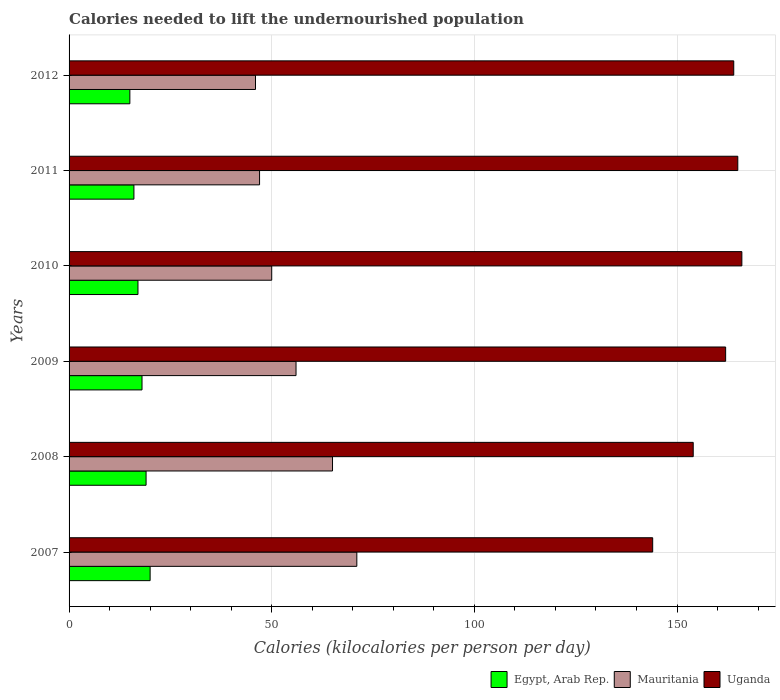How many different coloured bars are there?
Offer a very short reply. 3. Are the number of bars on each tick of the Y-axis equal?
Provide a short and direct response. Yes. How many bars are there on the 3rd tick from the bottom?
Provide a short and direct response. 3. What is the total calories needed to lift the undernourished population in Mauritania in 2010?
Your response must be concise. 50. Across all years, what is the maximum total calories needed to lift the undernourished population in Egypt, Arab Rep.?
Give a very brief answer. 20. Across all years, what is the minimum total calories needed to lift the undernourished population in Mauritania?
Your response must be concise. 46. In which year was the total calories needed to lift the undernourished population in Uganda maximum?
Give a very brief answer. 2010. In which year was the total calories needed to lift the undernourished population in Egypt, Arab Rep. minimum?
Provide a succinct answer. 2012. What is the total total calories needed to lift the undernourished population in Mauritania in the graph?
Give a very brief answer. 335. What is the difference between the total calories needed to lift the undernourished population in Egypt, Arab Rep. in 2007 and that in 2008?
Your answer should be compact. 1. What is the difference between the total calories needed to lift the undernourished population in Mauritania in 2009 and the total calories needed to lift the undernourished population in Egypt, Arab Rep. in 2007?
Provide a succinct answer. 36. What is the average total calories needed to lift the undernourished population in Mauritania per year?
Your response must be concise. 55.83. In the year 2008, what is the difference between the total calories needed to lift the undernourished population in Mauritania and total calories needed to lift the undernourished population in Egypt, Arab Rep.?
Your answer should be compact. 46. What is the ratio of the total calories needed to lift the undernourished population in Uganda in 2009 to that in 2011?
Offer a very short reply. 0.98. What is the difference between the highest and the lowest total calories needed to lift the undernourished population in Uganda?
Give a very brief answer. 22. In how many years, is the total calories needed to lift the undernourished population in Egypt, Arab Rep. greater than the average total calories needed to lift the undernourished population in Egypt, Arab Rep. taken over all years?
Offer a very short reply. 3. What does the 1st bar from the top in 2007 represents?
Offer a very short reply. Uganda. What does the 3rd bar from the bottom in 2009 represents?
Make the answer very short. Uganda. Is it the case that in every year, the sum of the total calories needed to lift the undernourished population in Egypt, Arab Rep. and total calories needed to lift the undernourished population in Uganda is greater than the total calories needed to lift the undernourished population in Mauritania?
Keep it short and to the point. Yes. How many bars are there?
Give a very brief answer. 18. Are all the bars in the graph horizontal?
Offer a terse response. Yes. Does the graph contain any zero values?
Your answer should be very brief. No. How are the legend labels stacked?
Provide a short and direct response. Horizontal. What is the title of the graph?
Give a very brief answer. Calories needed to lift the undernourished population. What is the label or title of the X-axis?
Offer a terse response. Calories (kilocalories per person per day). What is the label or title of the Y-axis?
Offer a terse response. Years. What is the Calories (kilocalories per person per day) in Mauritania in 2007?
Keep it short and to the point. 71. What is the Calories (kilocalories per person per day) in Uganda in 2007?
Offer a terse response. 144. What is the Calories (kilocalories per person per day) of Egypt, Arab Rep. in 2008?
Your answer should be compact. 19. What is the Calories (kilocalories per person per day) of Uganda in 2008?
Your response must be concise. 154. What is the Calories (kilocalories per person per day) of Uganda in 2009?
Provide a succinct answer. 162. What is the Calories (kilocalories per person per day) of Mauritania in 2010?
Ensure brevity in your answer.  50. What is the Calories (kilocalories per person per day) in Uganda in 2010?
Your response must be concise. 166. What is the Calories (kilocalories per person per day) in Egypt, Arab Rep. in 2011?
Provide a short and direct response. 16. What is the Calories (kilocalories per person per day) in Mauritania in 2011?
Offer a very short reply. 47. What is the Calories (kilocalories per person per day) in Uganda in 2011?
Your answer should be compact. 165. What is the Calories (kilocalories per person per day) in Egypt, Arab Rep. in 2012?
Keep it short and to the point. 15. What is the Calories (kilocalories per person per day) in Uganda in 2012?
Offer a terse response. 164. Across all years, what is the maximum Calories (kilocalories per person per day) in Egypt, Arab Rep.?
Provide a succinct answer. 20. Across all years, what is the maximum Calories (kilocalories per person per day) of Uganda?
Your answer should be compact. 166. Across all years, what is the minimum Calories (kilocalories per person per day) of Egypt, Arab Rep.?
Make the answer very short. 15. Across all years, what is the minimum Calories (kilocalories per person per day) of Uganda?
Provide a short and direct response. 144. What is the total Calories (kilocalories per person per day) of Egypt, Arab Rep. in the graph?
Your answer should be compact. 105. What is the total Calories (kilocalories per person per day) in Mauritania in the graph?
Make the answer very short. 335. What is the total Calories (kilocalories per person per day) in Uganda in the graph?
Give a very brief answer. 955. What is the difference between the Calories (kilocalories per person per day) of Mauritania in 2007 and that in 2008?
Provide a short and direct response. 6. What is the difference between the Calories (kilocalories per person per day) of Uganda in 2007 and that in 2008?
Your answer should be very brief. -10. What is the difference between the Calories (kilocalories per person per day) of Egypt, Arab Rep. in 2007 and that in 2009?
Your response must be concise. 2. What is the difference between the Calories (kilocalories per person per day) of Uganda in 2007 and that in 2009?
Give a very brief answer. -18. What is the difference between the Calories (kilocalories per person per day) in Egypt, Arab Rep. in 2007 and that in 2010?
Give a very brief answer. 3. What is the difference between the Calories (kilocalories per person per day) in Uganda in 2007 and that in 2010?
Your answer should be very brief. -22. What is the difference between the Calories (kilocalories per person per day) of Mauritania in 2007 and that in 2011?
Offer a very short reply. 24. What is the difference between the Calories (kilocalories per person per day) in Egypt, Arab Rep. in 2007 and that in 2012?
Offer a very short reply. 5. What is the difference between the Calories (kilocalories per person per day) in Uganda in 2007 and that in 2012?
Ensure brevity in your answer.  -20. What is the difference between the Calories (kilocalories per person per day) of Egypt, Arab Rep. in 2008 and that in 2009?
Make the answer very short. 1. What is the difference between the Calories (kilocalories per person per day) in Mauritania in 2008 and that in 2009?
Your answer should be very brief. 9. What is the difference between the Calories (kilocalories per person per day) of Mauritania in 2008 and that in 2010?
Offer a very short reply. 15. What is the difference between the Calories (kilocalories per person per day) in Egypt, Arab Rep. in 2008 and that in 2011?
Make the answer very short. 3. What is the difference between the Calories (kilocalories per person per day) of Egypt, Arab Rep. in 2008 and that in 2012?
Offer a very short reply. 4. What is the difference between the Calories (kilocalories per person per day) in Uganda in 2008 and that in 2012?
Make the answer very short. -10. What is the difference between the Calories (kilocalories per person per day) of Egypt, Arab Rep. in 2009 and that in 2010?
Give a very brief answer. 1. What is the difference between the Calories (kilocalories per person per day) of Uganda in 2009 and that in 2010?
Your response must be concise. -4. What is the difference between the Calories (kilocalories per person per day) in Mauritania in 2009 and that in 2012?
Offer a terse response. 10. What is the difference between the Calories (kilocalories per person per day) in Uganda in 2009 and that in 2012?
Your answer should be compact. -2. What is the difference between the Calories (kilocalories per person per day) of Egypt, Arab Rep. in 2010 and that in 2011?
Keep it short and to the point. 1. What is the difference between the Calories (kilocalories per person per day) of Mauritania in 2010 and that in 2012?
Offer a very short reply. 4. What is the difference between the Calories (kilocalories per person per day) in Egypt, Arab Rep. in 2011 and that in 2012?
Provide a short and direct response. 1. What is the difference between the Calories (kilocalories per person per day) in Mauritania in 2011 and that in 2012?
Offer a terse response. 1. What is the difference between the Calories (kilocalories per person per day) in Uganda in 2011 and that in 2012?
Your response must be concise. 1. What is the difference between the Calories (kilocalories per person per day) of Egypt, Arab Rep. in 2007 and the Calories (kilocalories per person per day) of Mauritania in 2008?
Provide a succinct answer. -45. What is the difference between the Calories (kilocalories per person per day) of Egypt, Arab Rep. in 2007 and the Calories (kilocalories per person per day) of Uganda in 2008?
Provide a succinct answer. -134. What is the difference between the Calories (kilocalories per person per day) of Mauritania in 2007 and the Calories (kilocalories per person per day) of Uganda in 2008?
Your answer should be very brief. -83. What is the difference between the Calories (kilocalories per person per day) in Egypt, Arab Rep. in 2007 and the Calories (kilocalories per person per day) in Mauritania in 2009?
Your answer should be very brief. -36. What is the difference between the Calories (kilocalories per person per day) of Egypt, Arab Rep. in 2007 and the Calories (kilocalories per person per day) of Uganda in 2009?
Your answer should be compact. -142. What is the difference between the Calories (kilocalories per person per day) of Mauritania in 2007 and the Calories (kilocalories per person per day) of Uganda in 2009?
Keep it short and to the point. -91. What is the difference between the Calories (kilocalories per person per day) in Egypt, Arab Rep. in 2007 and the Calories (kilocalories per person per day) in Mauritania in 2010?
Offer a terse response. -30. What is the difference between the Calories (kilocalories per person per day) of Egypt, Arab Rep. in 2007 and the Calories (kilocalories per person per day) of Uganda in 2010?
Keep it short and to the point. -146. What is the difference between the Calories (kilocalories per person per day) of Mauritania in 2007 and the Calories (kilocalories per person per day) of Uganda in 2010?
Provide a succinct answer. -95. What is the difference between the Calories (kilocalories per person per day) of Egypt, Arab Rep. in 2007 and the Calories (kilocalories per person per day) of Mauritania in 2011?
Offer a very short reply. -27. What is the difference between the Calories (kilocalories per person per day) of Egypt, Arab Rep. in 2007 and the Calories (kilocalories per person per day) of Uganda in 2011?
Provide a short and direct response. -145. What is the difference between the Calories (kilocalories per person per day) in Mauritania in 2007 and the Calories (kilocalories per person per day) in Uganda in 2011?
Your response must be concise. -94. What is the difference between the Calories (kilocalories per person per day) of Egypt, Arab Rep. in 2007 and the Calories (kilocalories per person per day) of Uganda in 2012?
Your answer should be compact. -144. What is the difference between the Calories (kilocalories per person per day) of Mauritania in 2007 and the Calories (kilocalories per person per day) of Uganda in 2012?
Your answer should be very brief. -93. What is the difference between the Calories (kilocalories per person per day) of Egypt, Arab Rep. in 2008 and the Calories (kilocalories per person per day) of Mauritania in 2009?
Ensure brevity in your answer.  -37. What is the difference between the Calories (kilocalories per person per day) in Egypt, Arab Rep. in 2008 and the Calories (kilocalories per person per day) in Uganda in 2009?
Give a very brief answer. -143. What is the difference between the Calories (kilocalories per person per day) of Mauritania in 2008 and the Calories (kilocalories per person per day) of Uganda in 2009?
Provide a short and direct response. -97. What is the difference between the Calories (kilocalories per person per day) of Egypt, Arab Rep. in 2008 and the Calories (kilocalories per person per day) of Mauritania in 2010?
Offer a very short reply. -31. What is the difference between the Calories (kilocalories per person per day) in Egypt, Arab Rep. in 2008 and the Calories (kilocalories per person per day) in Uganda in 2010?
Provide a succinct answer. -147. What is the difference between the Calories (kilocalories per person per day) in Mauritania in 2008 and the Calories (kilocalories per person per day) in Uganda in 2010?
Keep it short and to the point. -101. What is the difference between the Calories (kilocalories per person per day) in Egypt, Arab Rep. in 2008 and the Calories (kilocalories per person per day) in Mauritania in 2011?
Provide a succinct answer. -28. What is the difference between the Calories (kilocalories per person per day) of Egypt, Arab Rep. in 2008 and the Calories (kilocalories per person per day) of Uganda in 2011?
Your answer should be compact. -146. What is the difference between the Calories (kilocalories per person per day) of Mauritania in 2008 and the Calories (kilocalories per person per day) of Uganda in 2011?
Your answer should be very brief. -100. What is the difference between the Calories (kilocalories per person per day) in Egypt, Arab Rep. in 2008 and the Calories (kilocalories per person per day) in Mauritania in 2012?
Your answer should be very brief. -27. What is the difference between the Calories (kilocalories per person per day) in Egypt, Arab Rep. in 2008 and the Calories (kilocalories per person per day) in Uganda in 2012?
Offer a very short reply. -145. What is the difference between the Calories (kilocalories per person per day) in Mauritania in 2008 and the Calories (kilocalories per person per day) in Uganda in 2012?
Offer a terse response. -99. What is the difference between the Calories (kilocalories per person per day) in Egypt, Arab Rep. in 2009 and the Calories (kilocalories per person per day) in Mauritania in 2010?
Your response must be concise. -32. What is the difference between the Calories (kilocalories per person per day) in Egypt, Arab Rep. in 2009 and the Calories (kilocalories per person per day) in Uganda in 2010?
Give a very brief answer. -148. What is the difference between the Calories (kilocalories per person per day) in Mauritania in 2009 and the Calories (kilocalories per person per day) in Uganda in 2010?
Make the answer very short. -110. What is the difference between the Calories (kilocalories per person per day) of Egypt, Arab Rep. in 2009 and the Calories (kilocalories per person per day) of Uganda in 2011?
Provide a short and direct response. -147. What is the difference between the Calories (kilocalories per person per day) in Mauritania in 2009 and the Calories (kilocalories per person per day) in Uganda in 2011?
Your response must be concise. -109. What is the difference between the Calories (kilocalories per person per day) in Egypt, Arab Rep. in 2009 and the Calories (kilocalories per person per day) in Mauritania in 2012?
Your response must be concise. -28. What is the difference between the Calories (kilocalories per person per day) in Egypt, Arab Rep. in 2009 and the Calories (kilocalories per person per day) in Uganda in 2012?
Ensure brevity in your answer.  -146. What is the difference between the Calories (kilocalories per person per day) in Mauritania in 2009 and the Calories (kilocalories per person per day) in Uganda in 2012?
Your answer should be very brief. -108. What is the difference between the Calories (kilocalories per person per day) in Egypt, Arab Rep. in 2010 and the Calories (kilocalories per person per day) in Uganda in 2011?
Give a very brief answer. -148. What is the difference between the Calories (kilocalories per person per day) in Mauritania in 2010 and the Calories (kilocalories per person per day) in Uganda in 2011?
Make the answer very short. -115. What is the difference between the Calories (kilocalories per person per day) of Egypt, Arab Rep. in 2010 and the Calories (kilocalories per person per day) of Uganda in 2012?
Keep it short and to the point. -147. What is the difference between the Calories (kilocalories per person per day) in Mauritania in 2010 and the Calories (kilocalories per person per day) in Uganda in 2012?
Ensure brevity in your answer.  -114. What is the difference between the Calories (kilocalories per person per day) of Egypt, Arab Rep. in 2011 and the Calories (kilocalories per person per day) of Uganda in 2012?
Provide a short and direct response. -148. What is the difference between the Calories (kilocalories per person per day) in Mauritania in 2011 and the Calories (kilocalories per person per day) in Uganda in 2012?
Give a very brief answer. -117. What is the average Calories (kilocalories per person per day) in Mauritania per year?
Ensure brevity in your answer.  55.83. What is the average Calories (kilocalories per person per day) in Uganda per year?
Give a very brief answer. 159.17. In the year 2007, what is the difference between the Calories (kilocalories per person per day) in Egypt, Arab Rep. and Calories (kilocalories per person per day) in Mauritania?
Provide a succinct answer. -51. In the year 2007, what is the difference between the Calories (kilocalories per person per day) of Egypt, Arab Rep. and Calories (kilocalories per person per day) of Uganda?
Ensure brevity in your answer.  -124. In the year 2007, what is the difference between the Calories (kilocalories per person per day) of Mauritania and Calories (kilocalories per person per day) of Uganda?
Give a very brief answer. -73. In the year 2008, what is the difference between the Calories (kilocalories per person per day) of Egypt, Arab Rep. and Calories (kilocalories per person per day) of Mauritania?
Ensure brevity in your answer.  -46. In the year 2008, what is the difference between the Calories (kilocalories per person per day) of Egypt, Arab Rep. and Calories (kilocalories per person per day) of Uganda?
Ensure brevity in your answer.  -135. In the year 2008, what is the difference between the Calories (kilocalories per person per day) of Mauritania and Calories (kilocalories per person per day) of Uganda?
Offer a very short reply. -89. In the year 2009, what is the difference between the Calories (kilocalories per person per day) in Egypt, Arab Rep. and Calories (kilocalories per person per day) in Mauritania?
Your answer should be very brief. -38. In the year 2009, what is the difference between the Calories (kilocalories per person per day) of Egypt, Arab Rep. and Calories (kilocalories per person per day) of Uganda?
Provide a short and direct response. -144. In the year 2009, what is the difference between the Calories (kilocalories per person per day) in Mauritania and Calories (kilocalories per person per day) in Uganda?
Make the answer very short. -106. In the year 2010, what is the difference between the Calories (kilocalories per person per day) in Egypt, Arab Rep. and Calories (kilocalories per person per day) in Mauritania?
Your answer should be compact. -33. In the year 2010, what is the difference between the Calories (kilocalories per person per day) of Egypt, Arab Rep. and Calories (kilocalories per person per day) of Uganda?
Ensure brevity in your answer.  -149. In the year 2010, what is the difference between the Calories (kilocalories per person per day) of Mauritania and Calories (kilocalories per person per day) of Uganda?
Make the answer very short. -116. In the year 2011, what is the difference between the Calories (kilocalories per person per day) of Egypt, Arab Rep. and Calories (kilocalories per person per day) of Mauritania?
Offer a very short reply. -31. In the year 2011, what is the difference between the Calories (kilocalories per person per day) of Egypt, Arab Rep. and Calories (kilocalories per person per day) of Uganda?
Keep it short and to the point. -149. In the year 2011, what is the difference between the Calories (kilocalories per person per day) in Mauritania and Calories (kilocalories per person per day) in Uganda?
Give a very brief answer. -118. In the year 2012, what is the difference between the Calories (kilocalories per person per day) of Egypt, Arab Rep. and Calories (kilocalories per person per day) of Mauritania?
Your answer should be compact. -31. In the year 2012, what is the difference between the Calories (kilocalories per person per day) of Egypt, Arab Rep. and Calories (kilocalories per person per day) of Uganda?
Offer a very short reply. -149. In the year 2012, what is the difference between the Calories (kilocalories per person per day) of Mauritania and Calories (kilocalories per person per day) of Uganda?
Your response must be concise. -118. What is the ratio of the Calories (kilocalories per person per day) in Egypt, Arab Rep. in 2007 to that in 2008?
Offer a very short reply. 1.05. What is the ratio of the Calories (kilocalories per person per day) of Mauritania in 2007 to that in 2008?
Provide a succinct answer. 1.09. What is the ratio of the Calories (kilocalories per person per day) in Uganda in 2007 to that in 2008?
Your response must be concise. 0.94. What is the ratio of the Calories (kilocalories per person per day) of Mauritania in 2007 to that in 2009?
Provide a succinct answer. 1.27. What is the ratio of the Calories (kilocalories per person per day) in Uganda in 2007 to that in 2009?
Provide a succinct answer. 0.89. What is the ratio of the Calories (kilocalories per person per day) in Egypt, Arab Rep. in 2007 to that in 2010?
Your answer should be very brief. 1.18. What is the ratio of the Calories (kilocalories per person per day) in Mauritania in 2007 to that in 2010?
Provide a short and direct response. 1.42. What is the ratio of the Calories (kilocalories per person per day) of Uganda in 2007 to that in 2010?
Provide a succinct answer. 0.87. What is the ratio of the Calories (kilocalories per person per day) of Mauritania in 2007 to that in 2011?
Your answer should be compact. 1.51. What is the ratio of the Calories (kilocalories per person per day) of Uganda in 2007 to that in 2011?
Provide a succinct answer. 0.87. What is the ratio of the Calories (kilocalories per person per day) in Mauritania in 2007 to that in 2012?
Ensure brevity in your answer.  1.54. What is the ratio of the Calories (kilocalories per person per day) of Uganda in 2007 to that in 2012?
Your response must be concise. 0.88. What is the ratio of the Calories (kilocalories per person per day) in Egypt, Arab Rep. in 2008 to that in 2009?
Provide a succinct answer. 1.06. What is the ratio of the Calories (kilocalories per person per day) in Mauritania in 2008 to that in 2009?
Provide a succinct answer. 1.16. What is the ratio of the Calories (kilocalories per person per day) in Uganda in 2008 to that in 2009?
Keep it short and to the point. 0.95. What is the ratio of the Calories (kilocalories per person per day) of Egypt, Arab Rep. in 2008 to that in 2010?
Your answer should be very brief. 1.12. What is the ratio of the Calories (kilocalories per person per day) of Mauritania in 2008 to that in 2010?
Your response must be concise. 1.3. What is the ratio of the Calories (kilocalories per person per day) of Uganda in 2008 to that in 2010?
Make the answer very short. 0.93. What is the ratio of the Calories (kilocalories per person per day) of Egypt, Arab Rep. in 2008 to that in 2011?
Keep it short and to the point. 1.19. What is the ratio of the Calories (kilocalories per person per day) of Mauritania in 2008 to that in 2011?
Your answer should be very brief. 1.38. What is the ratio of the Calories (kilocalories per person per day) of Egypt, Arab Rep. in 2008 to that in 2012?
Offer a very short reply. 1.27. What is the ratio of the Calories (kilocalories per person per day) in Mauritania in 2008 to that in 2012?
Your response must be concise. 1.41. What is the ratio of the Calories (kilocalories per person per day) of Uganda in 2008 to that in 2012?
Offer a terse response. 0.94. What is the ratio of the Calories (kilocalories per person per day) in Egypt, Arab Rep. in 2009 to that in 2010?
Provide a succinct answer. 1.06. What is the ratio of the Calories (kilocalories per person per day) in Mauritania in 2009 to that in 2010?
Offer a terse response. 1.12. What is the ratio of the Calories (kilocalories per person per day) of Uganda in 2009 to that in 2010?
Give a very brief answer. 0.98. What is the ratio of the Calories (kilocalories per person per day) of Egypt, Arab Rep. in 2009 to that in 2011?
Ensure brevity in your answer.  1.12. What is the ratio of the Calories (kilocalories per person per day) in Mauritania in 2009 to that in 2011?
Your response must be concise. 1.19. What is the ratio of the Calories (kilocalories per person per day) in Uganda in 2009 to that in 2011?
Make the answer very short. 0.98. What is the ratio of the Calories (kilocalories per person per day) in Mauritania in 2009 to that in 2012?
Offer a terse response. 1.22. What is the ratio of the Calories (kilocalories per person per day) in Egypt, Arab Rep. in 2010 to that in 2011?
Ensure brevity in your answer.  1.06. What is the ratio of the Calories (kilocalories per person per day) of Mauritania in 2010 to that in 2011?
Your answer should be very brief. 1.06. What is the ratio of the Calories (kilocalories per person per day) in Uganda in 2010 to that in 2011?
Your answer should be very brief. 1.01. What is the ratio of the Calories (kilocalories per person per day) of Egypt, Arab Rep. in 2010 to that in 2012?
Provide a succinct answer. 1.13. What is the ratio of the Calories (kilocalories per person per day) in Mauritania in 2010 to that in 2012?
Your answer should be compact. 1.09. What is the ratio of the Calories (kilocalories per person per day) in Uganda in 2010 to that in 2012?
Give a very brief answer. 1.01. What is the ratio of the Calories (kilocalories per person per day) of Egypt, Arab Rep. in 2011 to that in 2012?
Keep it short and to the point. 1.07. What is the ratio of the Calories (kilocalories per person per day) in Mauritania in 2011 to that in 2012?
Your response must be concise. 1.02. What is the ratio of the Calories (kilocalories per person per day) of Uganda in 2011 to that in 2012?
Give a very brief answer. 1.01. What is the difference between the highest and the second highest Calories (kilocalories per person per day) of Mauritania?
Ensure brevity in your answer.  6. What is the difference between the highest and the second highest Calories (kilocalories per person per day) in Uganda?
Your response must be concise. 1. What is the difference between the highest and the lowest Calories (kilocalories per person per day) in Egypt, Arab Rep.?
Provide a succinct answer. 5. What is the difference between the highest and the lowest Calories (kilocalories per person per day) in Uganda?
Offer a very short reply. 22. 